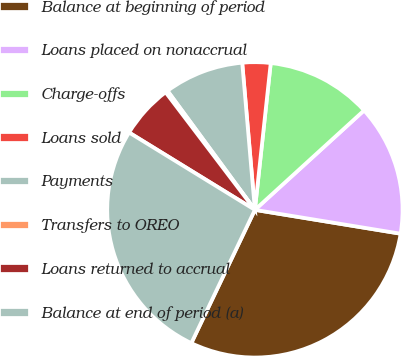Convert chart. <chart><loc_0><loc_0><loc_500><loc_500><pie_chart><fcel>Balance at beginning of period<fcel>Loans placed on nonaccrual<fcel>Charge-offs<fcel>Loans sold<fcel>Payments<fcel>Transfers to OREO<fcel>Loans returned to accrual<fcel>Balance at end of period (a)<nl><fcel>29.5%<fcel>14.34%<fcel>11.53%<fcel>3.08%<fcel>8.71%<fcel>0.26%<fcel>5.89%<fcel>26.69%<nl></chart> 